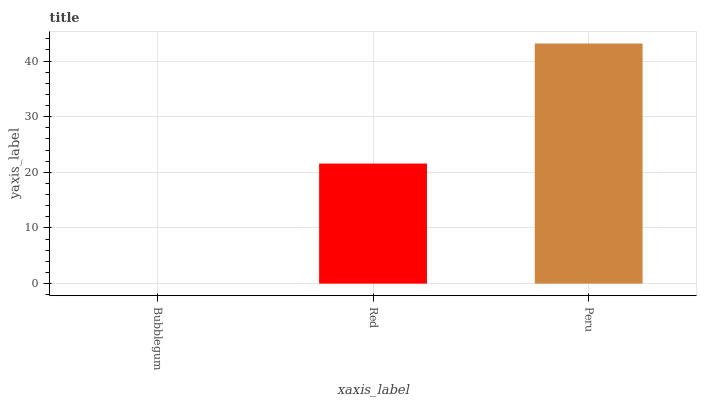Is Bubblegum the minimum?
Answer yes or no. Yes. Is Peru the maximum?
Answer yes or no. Yes. Is Red the minimum?
Answer yes or no. No. Is Red the maximum?
Answer yes or no. No. Is Red greater than Bubblegum?
Answer yes or no. Yes. Is Bubblegum less than Red?
Answer yes or no. Yes. Is Bubblegum greater than Red?
Answer yes or no. No. Is Red less than Bubblegum?
Answer yes or no. No. Is Red the high median?
Answer yes or no. Yes. Is Red the low median?
Answer yes or no. Yes. Is Peru the high median?
Answer yes or no. No. Is Peru the low median?
Answer yes or no. No. 